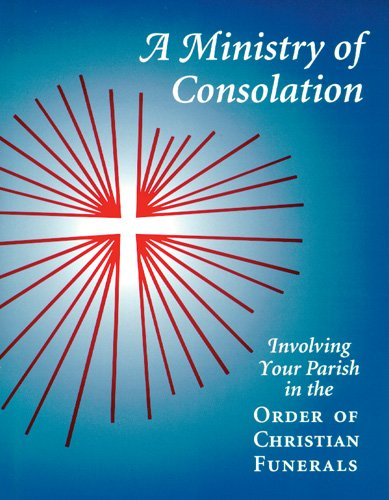Is this book related to Christian Books & Bibles? Yes, this book is indeed related to the 'Christian Books & Bibles' genre, as it discusses the Christian practices surrounding funerals and consolation. 